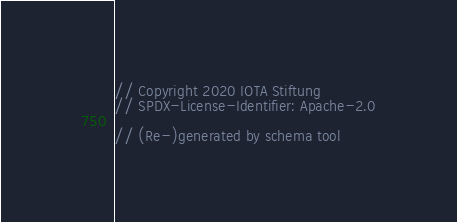<code> <loc_0><loc_0><loc_500><loc_500><_Rust_>// Copyright 2020 IOTA Stiftung
// SPDX-License-Identifier: Apache-2.0

// (Re-)generated by schema tool</code> 